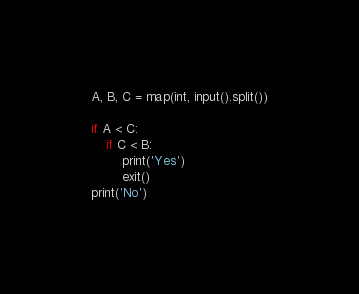Convert code to text. <code><loc_0><loc_0><loc_500><loc_500><_Python_>A, B, C = map(int, input().split())

if A < C:
    if C < B:
        print('Yes')
        exit()
print('No')</code> 